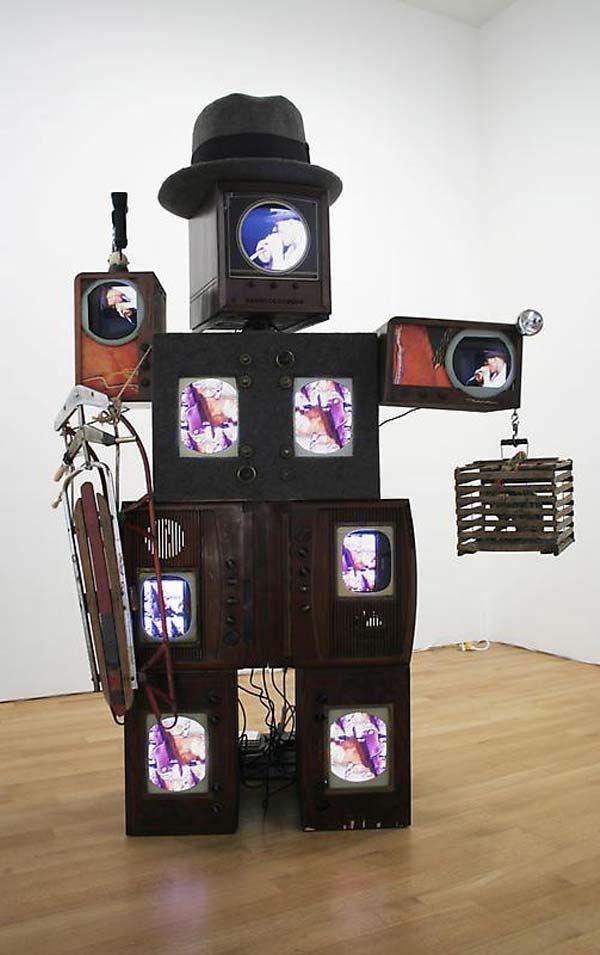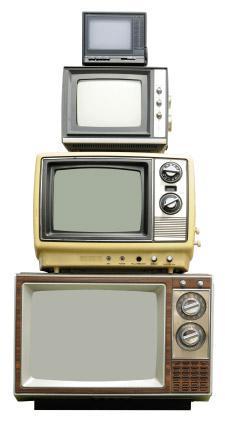The first image is the image on the left, the second image is the image on the right. Considering the images on both sides, is "In one image, the monitors are stacked in the shape of an animal or person." valid? Answer yes or no. Yes. The first image is the image on the left, the second image is the image on the right. For the images displayed, is the sentence "Tv's are stacked on a wood floor with a white wall" factually correct? Answer yes or no. Yes. 